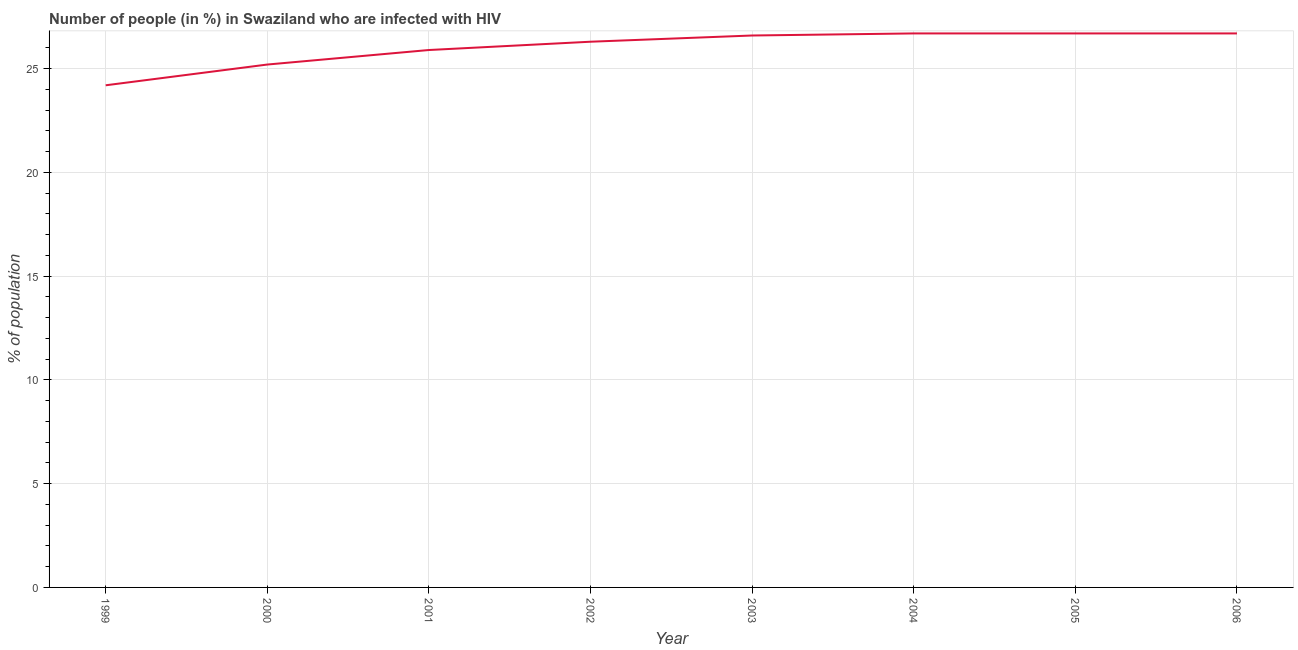What is the number of people infected with hiv in 2002?
Provide a short and direct response. 26.3. Across all years, what is the maximum number of people infected with hiv?
Ensure brevity in your answer.  26.7. Across all years, what is the minimum number of people infected with hiv?
Ensure brevity in your answer.  24.2. In which year was the number of people infected with hiv minimum?
Keep it short and to the point. 1999. What is the sum of the number of people infected with hiv?
Keep it short and to the point. 208.3. What is the average number of people infected with hiv per year?
Offer a terse response. 26.04. What is the median number of people infected with hiv?
Offer a terse response. 26.45. What is the ratio of the number of people infected with hiv in 2003 to that in 2006?
Offer a very short reply. 1. Is the number of people infected with hiv in 2000 less than that in 2004?
Offer a terse response. Yes. Is the difference between the number of people infected with hiv in 2002 and 2003 greater than the difference between any two years?
Your answer should be compact. No. What is the difference between the highest and the second highest number of people infected with hiv?
Offer a very short reply. 0. Is the sum of the number of people infected with hiv in 2002 and 2004 greater than the maximum number of people infected with hiv across all years?
Your answer should be very brief. Yes. What is the difference between the highest and the lowest number of people infected with hiv?
Provide a short and direct response. 2.5. In how many years, is the number of people infected with hiv greater than the average number of people infected with hiv taken over all years?
Provide a short and direct response. 5. Does the number of people infected with hiv monotonically increase over the years?
Provide a succinct answer. No. How many lines are there?
Provide a succinct answer. 1. What is the difference between two consecutive major ticks on the Y-axis?
Keep it short and to the point. 5. Are the values on the major ticks of Y-axis written in scientific E-notation?
Provide a succinct answer. No. Does the graph contain grids?
Your answer should be compact. Yes. What is the title of the graph?
Provide a succinct answer. Number of people (in %) in Swaziland who are infected with HIV. What is the label or title of the X-axis?
Your answer should be compact. Year. What is the label or title of the Y-axis?
Provide a succinct answer. % of population. What is the % of population in 1999?
Provide a short and direct response. 24.2. What is the % of population in 2000?
Your answer should be compact. 25.2. What is the % of population in 2001?
Make the answer very short. 25.9. What is the % of population of 2002?
Offer a terse response. 26.3. What is the % of population in 2003?
Give a very brief answer. 26.6. What is the % of population of 2004?
Your answer should be compact. 26.7. What is the % of population of 2005?
Provide a succinct answer. 26.7. What is the % of population in 2006?
Your response must be concise. 26.7. What is the difference between the % of population in 1999 and 2000?
Ensure brevity in your answer.  -1. What is the difference between the % of population in 1999 and 2001?
Ensure brevity in your answer.  -1.7. What is the difference between the % of population in 1999 and 2003?
Your response must be concise. -2.4. What is the difference between the % of population in 2000 and 2001?
Offer a very short reply. -0.7. What is the difference between the % of population in 2000 and 2002?
Provide a succinct answer. -1.1. What is the difference between the % of population in 2000 and 2004?
Keep it short and to the point. -1.5. What is the difference between the % of population in 2001 and 2002?
Make the answer very short. -0.4. What is the difference between the % of population in 2001 and 2003?
Your response must be concise. -0.7. What is the difference between the % of population in 2001 and 2005?
Your response must be concise. -0.8. What is the difference between the % of population in 2001 and 2006?
Make the answer very short. -0.8. What is the difference between the % of population in 2002 and 2004?
Your response must be concise. -0.4. What is the difference between the % of population in 2002 and 2006?
Your response must be concise. -0.4. What is the difference between the % of population in 2003 and 2006?
Give a very brief answer. -0.1. What is the difference between the % of population in 2005 and 2006?
Offer a very short reply. 0. What is the ratio of the % of population in 1999 to that in 2000?
Your answer should be compact. 0.96. What is the ratio of the % of population in 1999 to that in 2001?
Provide a short and direct response. 0.93. What is the ratio of the % of population in 1999 to that in 2002?
Ensure brevity in your answer.  0.92. What is the ratio of the % of population in 1999 to that in 2003?
Your answer should be compact. 0.91. What is the ratio of the % of population in 1999 to that in 2004?
Provide a short and direct response. 0.91. What is the ratio of the % of population in 1999 to that in 2005?
Offer a terse response. 0.91. What is the ratio of the % of population in 1999 to that in 2006?
Provide a short and direct response. 0.91. What is the ratio of the % of population in 2000 to that in 2002?
Your response must be concise. 0.96. What is the ratio of the % of population in 2000 to that in 2003?
Give a very brief answer. 0.95. What is the ratio of the % of population in 2000 to that in 2004?
Give a very brief answer. 0.94. What is the ratio of the % of population in 2000 to that in 2005?
Give a very brief answer. 0.94. What is the ratio of the % of population in 2000 to that in 2006?
Provide a short and direct response. 0.94. What is the ratio of the % of population in 2001 to that in 2002?
Your response must be concise. 0.98. What is the ratio of the % of population in 2001 to that in 2003?
Give a very brief answer. 0.97. What is the ratio of the % of population in 2001 to that in 2005?
Your response must be concise. 0.97. What is the ratio of the % of population in 2001 to that in 2006?
Offer a very short reply. 0.97. What is the ratio of the % of population in 2002 to that in 2006?
Give a very brief answer. 0.98. What is the ratio of the % of population in 2003 to that in 2005?
Your response must be concise. 1. What is the ratio of the % of population in 2004 to that in 2006?
Provide a short and direct response. 1. What is the ratio of the % of population in 2005 to that in 2006?
Your response must be concise. 1. 